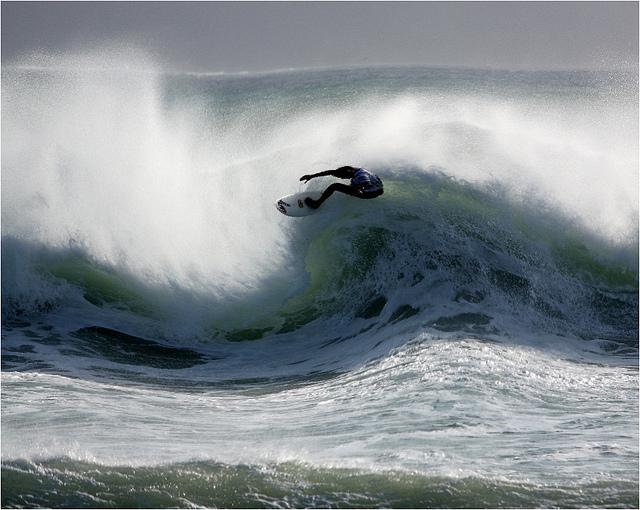What is the person doing?
Write a very short answer. Surfing. Is it a sunny or clouding day?
Quick response, please. Cloudy. Is the water clam?
Keep it brief. No. 